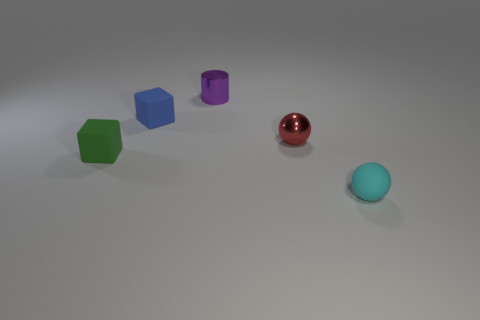Add 2 cubes. How many objects exist? 7 Subtract all balls. How many objects are left? 3 Subtract all small red spheres. Subtract all purple things. How many objects are left? 3 Add 2 small red things. How many small red things are left? 3 Add 5 tiny cylinders. How many tiny cylinders exist? 6 Subtract 1 red spheres. How many objects are left? 4 